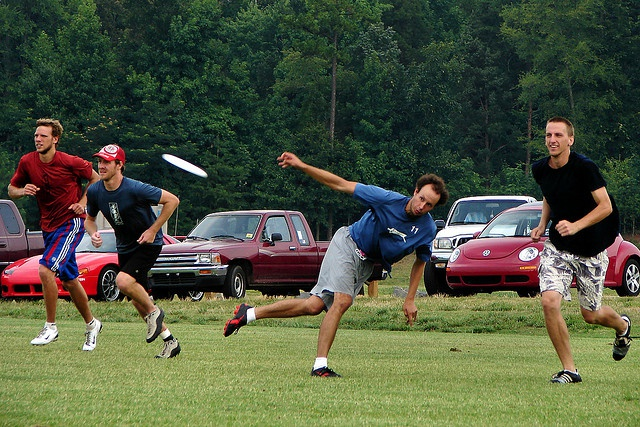Describe the objects in this image and their specific colors. I can see people in gray, black, navy, and darkgray tones, people in gray, black, ivory, and darkgray tones, truck in gray, black, darkgray, and maroon tones, people in gray, maroon, black, brown, and white tones, and people in gray, black, salmon, tan, and navy tones in this image. 